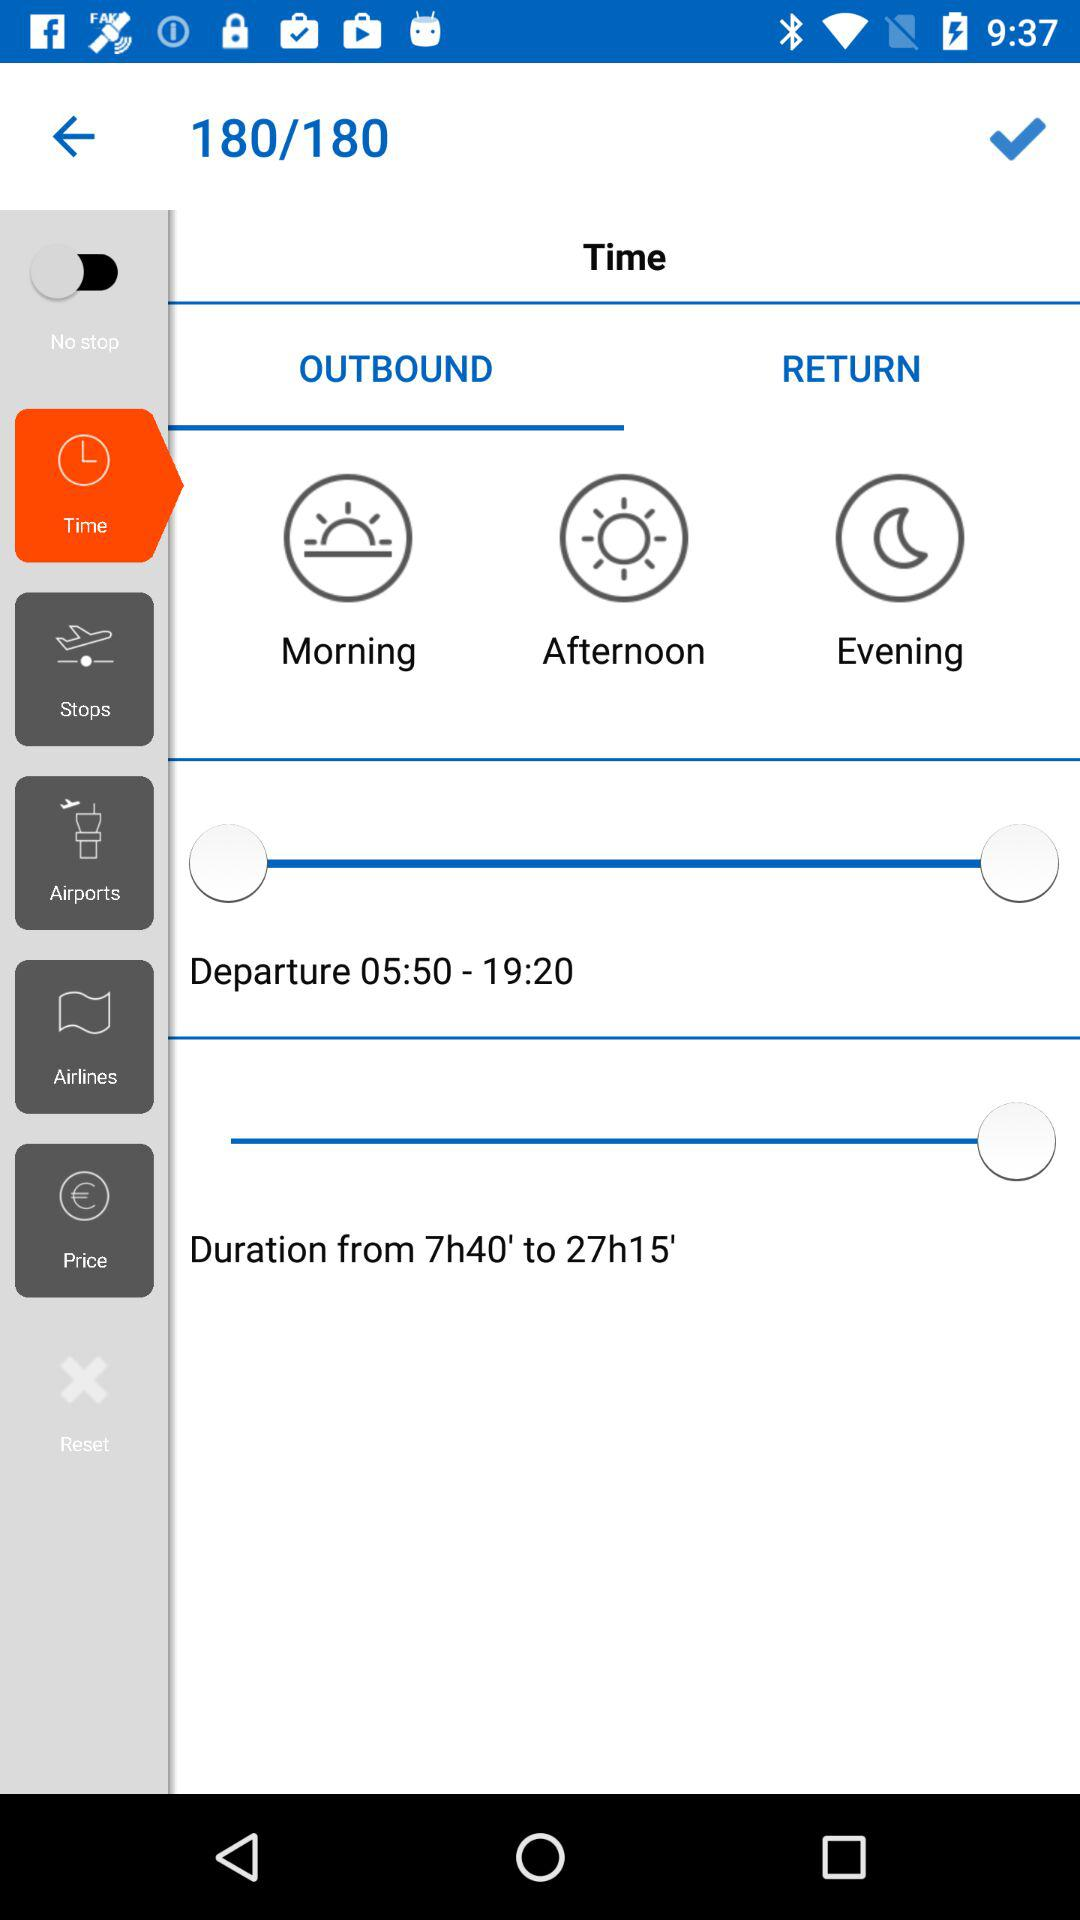What is the total number of pages? The total number of pages is 180. 